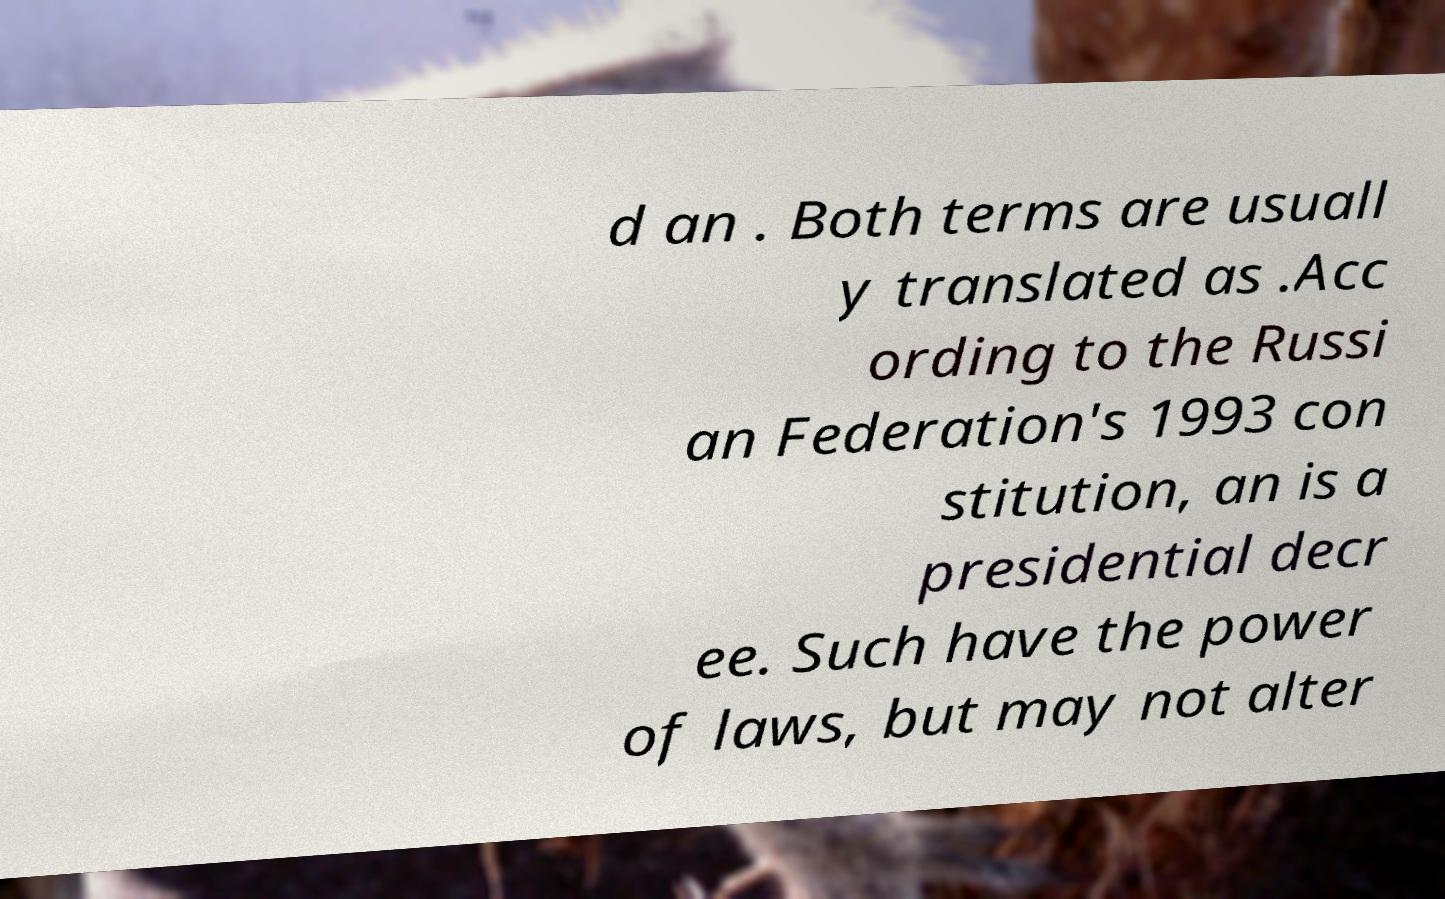For documentation purposes, I need the text within this image transcribed. Could you provide that? d an . Both terms are usuall y translated as .Acc ording to the Russi an Federation's 1993 con stitution, an is a presidential decr ee. Such have the power of laws, but may not alter 